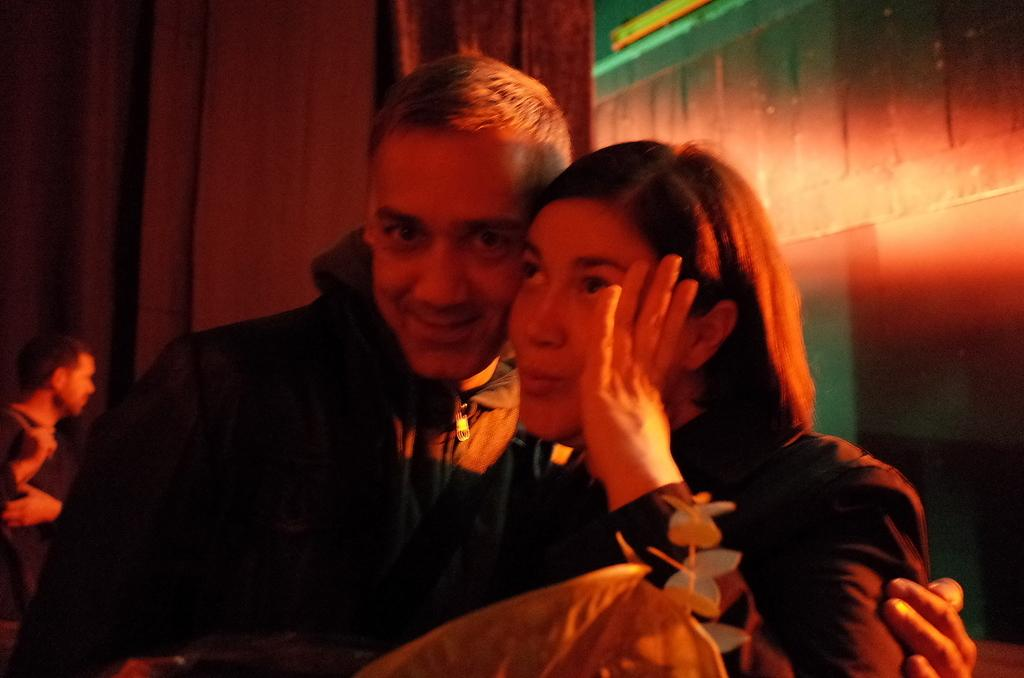How many individuals are present in the image? There are three people in the image. Can you describe the background of the image? There is a wall in the background of the image. How many chairs are visible in the image? There is no mention of chairs in the provided facts, so we cannot determine the number of chairs present in the image. 